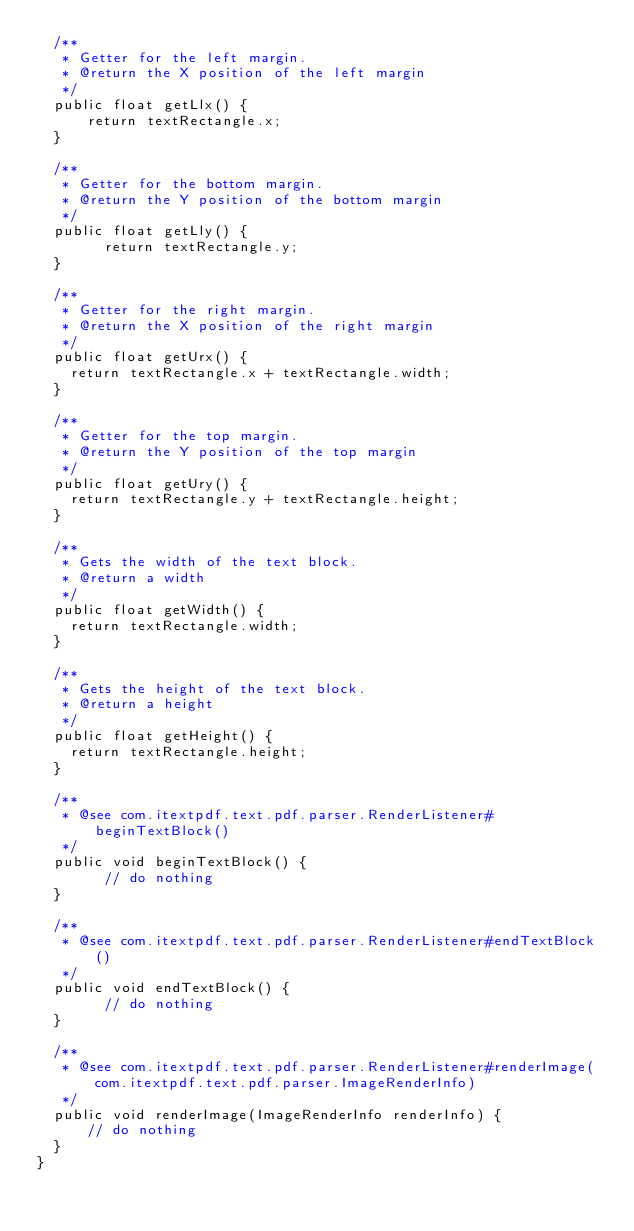<code> <loc_0><loc_0><loc_500><loc_500><_Java_>	/**
	 * Getter for the left margin.
	 * @return the X position of the left margin
	 */
	public float getLlx() {
	    return textRectangle.x;
	}

	/**
	 * Getter for the bottom margin.
	 * @return the Y position of the bottom margin
	 */
	public float getLly() {
        return textRectangle.y;
	}

	/**
	 * Getter for the right margin.
	 * @return the X position of the right margin
	 */
	public float getUrx() {
		return textRectangle.x + textRectangle.width;
	}

	/**
	 * Getter for the top margin.
	 * @return the Y position of the top margin
	 */
	public float getUry() {
		return textRectangle.y + textRectangle.height;
	}

	/**
	 * Gets the width of the text block.
	 * @return a width
	 */
	public float getWidth() {
		return textRectangle.width;
	}
	
	/**
	 * Gets the height of the text block.
	 * @return a height
	 */
	public float getHeight() {
		return textRectangle.height;
	}
	
	/**
	 * @see com.itextpdf.text.pdf.parser.RenderListener#beginTextBlock()
	 */
	public void beginTextBlock() {
        // do nothing
	}

	/**
	 * @see com.itextpdf.text.pdf.parser.RenderListener#endTextBlock()
	 */
	public void endTextBlock() {
        // do nothing
	}

	/**
	 * @see com.itextpdf.text.pdf.parser.RenderListener#renderImage(com.itextpdf.text.pdf.parser.ImageRenderInfo)
	 */
	public void renderImage(ImageRenderInfo renderInfo) {
	    // do nothing
	}
}
</code> 